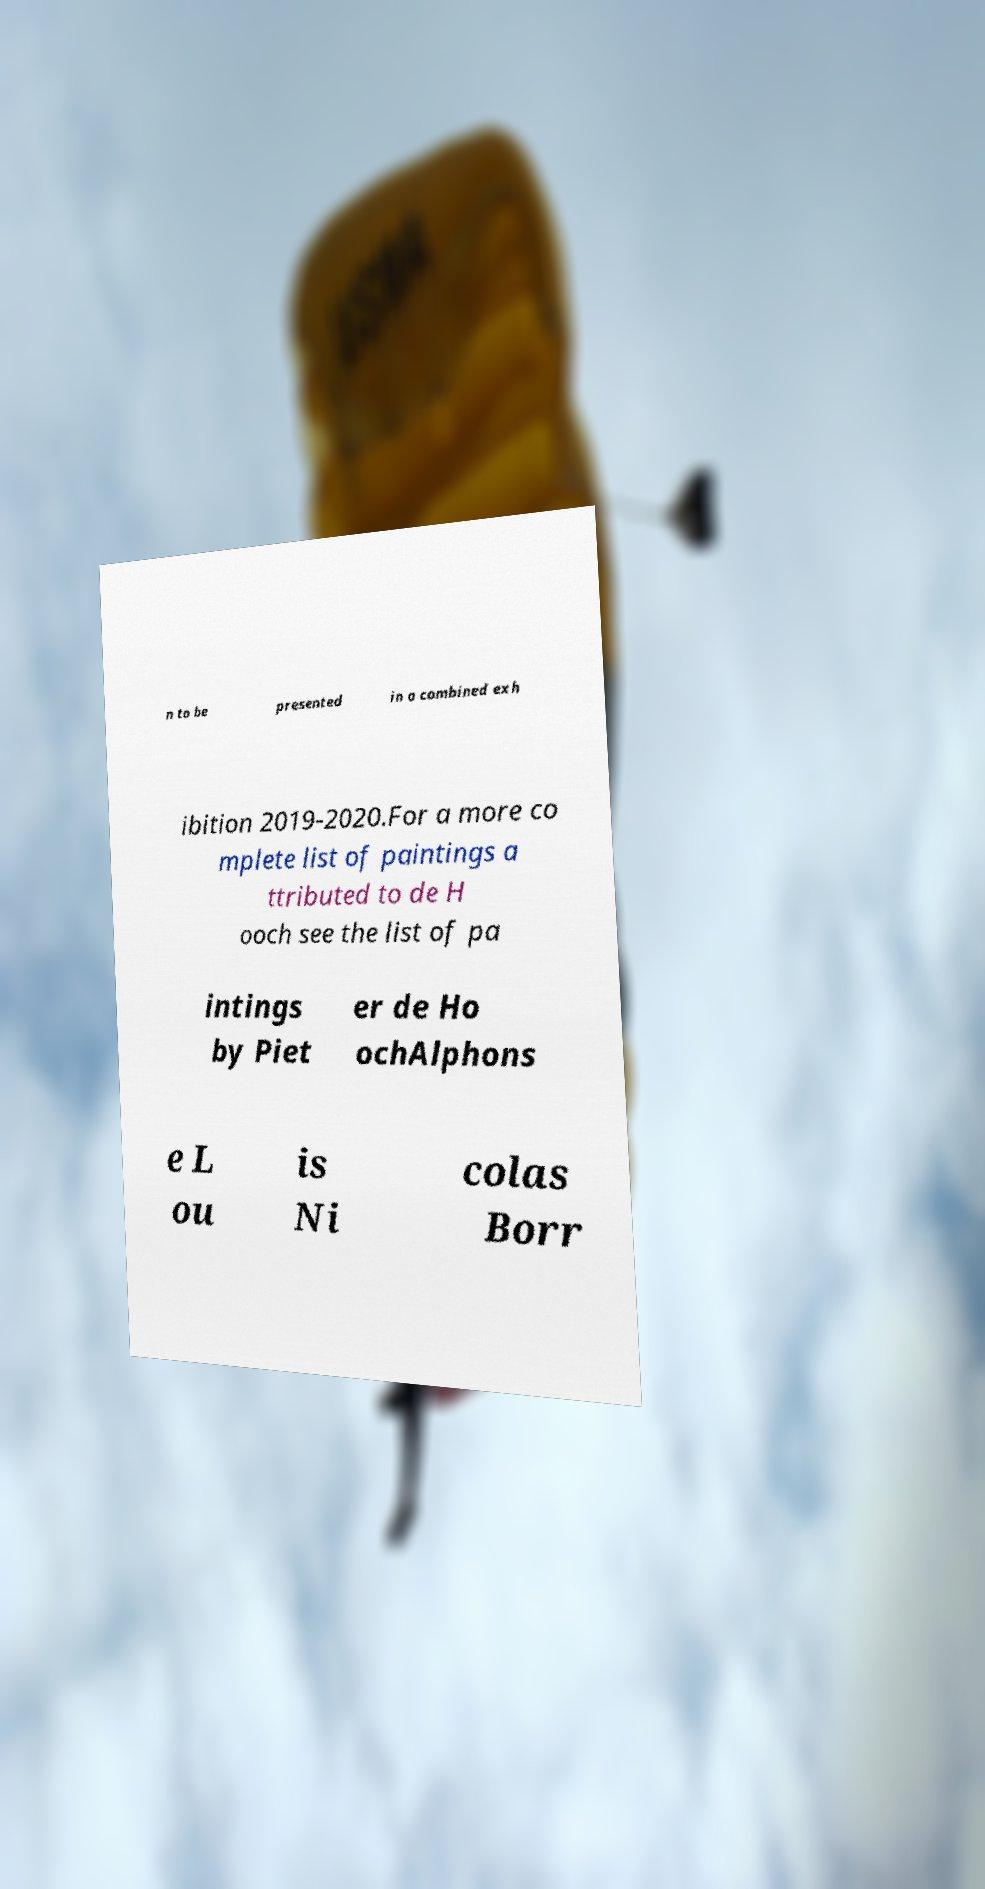Please identify and transcribe the text found in this image. n to be presented in a combined exh ibition 2019-2020.For a more co mplete list of paintings a ttributed to de H ooch see the list of pa intings by Piet er de Ho ochAlphons e L ou is Ni colas Borr 